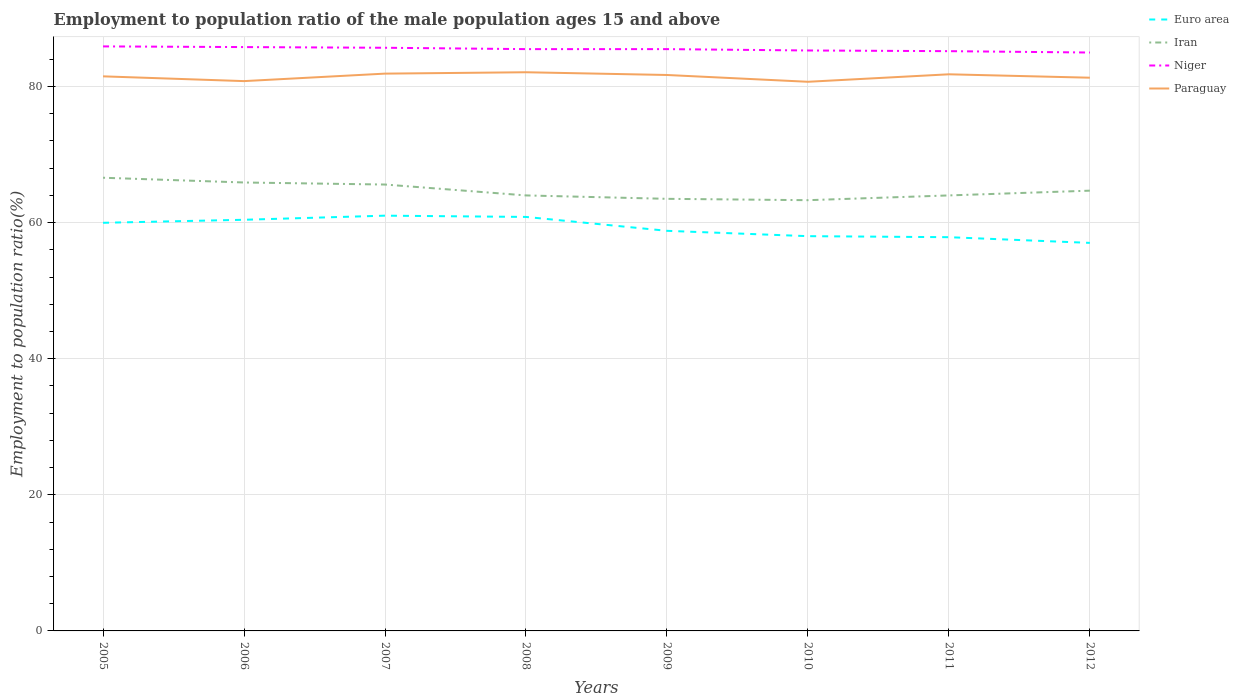How many different coloured lines are there?
Ensure brevity in your answer.  4. Does the line corresponding to Niger intersect with the line corresponding to Paraguay?
Offer a terse response. No. Is the number of lines equal to the number of legend labels?
Offer a very short reply. Yes. In which year was the employment to population ratio in Niger maximum?
Ensure brevity in your answer.  2012. What is the total employment to population ratio in Euro area in the graph?
Make the answer very short. 2.83. What is the difference between the highest and the second highest employment to population ratio in Iran?
Your answer should be compact. 3.3. What is the difference between the highest and the lowest employment to population ratio in Niger?
Your answer should be compact. 5. How many lines are there?
Make the answer very short. 4. How many years are there in the graph?
Your response must be concise. 8. What is the difference between two consecutive major ticks on the Y-axis?
Give a very brief answer. 20. Are the values on the major ticks of Y-axis written in scientific E-notation?
Give a very brief answer. No. Does the graph contain grids?
Provide a succinct answer. Yes. Where does the legend appear in the graph?
Your answer should be compact. Top right. How many legend labels are there?
Make the answer very short. 4. How are the legend labels stacked?
Provide a short and direct response. Vertical. What is the title of the graph?
Ensure brevity in your answer.  Employment to population ratio of the male population ages 15 and above. Does "Seychelles" appear as one of the legend labels in the graph?
Provide a succinct answer. No. What is the Employment to population ratio(%) of Euro area in 2005?
Your response must be concise. 59.98. What is the Employment to population ratio(%) in Iran in 2005?
Provide a short and direct response. 66.6. What is the Employment to population ratio(%) in Niger in 2005?
Ensure brevity in your answer.  85.9. What is the Employment to population ratio(%) in Paraguay in 2005?
Keep it short and to the point. 81.5. What is the Employment to population ratio(%) of Euro area in 2006?
Ensure brevity in your answer.  60.42. What is the Employment to population ratio(%) of Iran in 2006?
Give a very brief answer. 65.9. What is the Employment to population ratio(%) of Niger in 2006?
Make the answer very short. 85.8. What is the Employment to population ratio(%) in Paraguay in 2006?
Offer a terse response. 80.8. What is the Employment to population ratio(%) of Euro area in 2007?
Keep it short and to the point. 61.03. What is the Employment to population ratio(%) of Iran in 2007?
Offer a terse response. 65.6. What is the Employment to population ratio(%) of Niger in 2007?
Provide a succinct answer. 85.7. What is the Employment to population ratio(%) in Paraguay in 2007?
Keep it short and to the point. 81.9. What is the Employment to population ratio(%) in Euro area in 2008?
Give a very brief answer. 60.84. What is the Employment to population ratio(%) in Iran in 2008?
Your response must be concise. 64. What is the Employment to population ratio(%) in Niger in 2008?
Your response must be concise. 85.5. What is the Employment to population ratio(%) in Paraguay in 2008?
Give a very brief answer. 82.1. What is the Employment to population ratio(%) of Euro area in 2009?
Your answer should be compact. 58.8. What is the Employment to population ratio(%) in Iran in 2009?
Your answer should be compact. 63.5. What is the Employment to population ratio(%) of Niger in 2009?
Give a very brief answer. 85.5. What is the Employment to population ratio(%) in Paraguay in 2009?
Your answer should be compact. 81.7. What is the Employment to population ratio(%) in Euro area in 2010?
Provide a short and direct response. 58.01. What is the Employment to population ratio(%) of Iran in 2010?
Make the answer very short. 63.3. What is the Employment to population ratio(%) in Niger in 2010?
Provide a short and direct response. 85.3. What is the Employment to population ratio(%) in Paraguay in 2010?
Your answer should be compact. 80.7. What is the Employment to population ratio(%) in Euro area in 2011?
Offer a terse response. 57.86. What is the Employment to population ratio(%) of Iran in 2011?
Your answer should be very brief. 64. What is the Employment to population ratio(%) in Niger in 2011?
Ensure brevity in your answer.  85.2. What is the Employment to population ratio(%) of Paraguay in 2011?
Make the answer very short. 81.8. What is the Employment to population ratio(%) of Euro area in 2012?
Make the answer very short. 57.02. What is the Employment to population ratio(%) of Iran in 2012?
Your answer should be compact. 64.7. What is the Employment to population ratio(%) in Paraguay in 2012?
Give a very brief answer. 81.3. Across all years, what is the maximum Employment to population ratio(%) of Euro area?
Give a very brief answer. 61.03. Across all years, what is the maximum Employment to population ratio(%) of Iran?
Provide a short and direct response. 66.6. Across all years, what is the maximum Employment to population ratio(%) in Niger?
Ensure brevity in your answer.  85.9. Across all years, what is the maximum Employment to population ratio(%) of Paraguay?
Your answer should be compact. 82.1. Across all years, what is the minimum Employment to population ratio(%) in Euro area?
Provide a short and direct response. 57.02. Across all years, what is the minimum Employment to population ratio(%) of Iran?
Offer a terse response. 63.3. Across all years, what is the minimum Employment to population ratio(%) in Niger?
Offer a very short reply. 85. Across all years, what is the minimum Employment to population ratio(%) of Paraguay?
Provide a succinct answer. 80.7. What is the total Employment to population ratio(%) in Euro area in the graph?
Offer a very short reply. 473.96. What is the total Employment to population ratio(%) of Iran in the graph?
Give a very brief answer. 517.6. What is the total Employment to population ratio(%) in Niger in the graph?
Make the answer very short. 683.9. What is the total Employment to population ratio(%) in Paraguay in the graph?
Your answer should be compact. 651.8. What is the difference between the Employment to population ratio(%) of Euro area in 2005 and that in 2006?
Keep it short and to the point. -0.44. What is the difference between the Employment to population ratio(%) in Niger in 2005 and that in 2006?
Ensure brevity in your answer.  0.1. What is the difference between the Employment to population ratio(%) in Euro area in 2005 and that in 2007?
Offer a terse response. -1.05. What is the difference between the Employment to population ratio(%) in Niger in 2005 and that in 2007?
Offer a terse response. 0.2. What is the difference between the Employment to population ratio(%) of Euro area in 2005 and that in 2008?
Ensure brevity in your answer.  -0.86. What is the difference between the Employment to population ratio(%) in Iran in 2005 and that in 2008?
Ensure brevity in your answer.  2.6. What is the difference between the Employment to population ratio(%) of Euro area in 2005 and that in 2009?
Ensure brevity in your answer.  1.18. What is the difference between the Employment to population ratio(%) of Paraguay in 2005 and that in 2009?
Your answer should be compact. -0.2. What is the difference between the Employment to population ratio(%) in Euro area in 2005 and that in 2010?
Keep it short and to the point. 1.96. What is the difference between the Employment to population ratio(%) of Paraguay in 2005 and that in 2010?
Provide a succinct answer. 0.8. What is the difference between the Employment to population ratio(%) of Euro area in 2005 and that in 2011?
Give a very brief answer. 2.12. What is the difference between the Employment to population ratio(%) of Paraguay in 2005 and that in 2011?
Provide a short and direct response. -0.3. What is the difference between the Employment to population ratio(%) in Euro area in 2005 and that in 2012?
Provide a short and direct response. 2.95. What is the difference between the Employment to population ratio(%) in Niger in 2005 and that in 2012?
Keep it short and to the point. 0.9. What is the difference between the Employment to population ratio(%) in Euro area in 2006 and that in 2007?
Your response must be concise. -0.6. What is the difference between the Employment to population ratio(%) of Iran in 2006 and that in 2007?
Keep it short and to the point. 0.3. What is the difference between the Employment to population ratio(%) of Euro area in 2006 and that in 2008?
Your response must be concise. -0.42. What is the difference between the Employment to population ratio(%) in Paraguay in 2006 and that in 2008?
Offer a terse response. -1.3. What is the difference between the Employment to population ratio(%) in Euro area in 2006 and that in 2009?
Ensure brevity in your answer.  1.62. What is the difference between the Employment to population ratio(%) in Niger in 2006 and that in 2009?
Provide a succinct answer. 0.3. What is the difference between the Employment to population ratio(%) in Paraguay in 2006 and that in 2009?
Your response must be concise. -0.9. What is the difference between the Employment to population ratio(%) in Euro area in 2006 and that in 2010?
Offer a terse response. 2.41. What is the difference between the Employment to population ratio(%) in Iran in 2006 and that in 2010?
Your response must be concise. 2.6. What is the difference between the Employment to population ratio(%) of Paraguay in 2006 and that in 2010?
Offer a very short reply. 0.1. What is the difference between the Employment to population ratio(%) of Euro area in 2006 and that in 2011?
Your answer should be compact. 2.56. What is the difference between the Employment to population ratio(%) in Niger in 2006 and that in 2011?
Your answer should be very brief. 0.6. What is the difference between the Employment to population ratio(%) of Paraguay in 2006 and that in 2011?
Offer a very short reply. -1. What is the difference between the Employment to population ratio(%) in Euro area in 2006 and that in 2012?
Your answer should be compact. 3.4. What is the difference between the Employment to population ratio(%) of Iran in 2006 and that in 2012?
Your answer should be very brief. 1.2. What is the difference between the Employment to population ratio(%) in Niger in 2006 and that in 2012?
Offer a terse response. 0.8. What is the difference between the Employment to population ratio(%) in Paraguay in 2006 and that in 2012?
Give a very brief answer. -0.5. What is the difference between the Employment to population ratio(%) of Euro area in 2007 and that in 2008?
Your response must be concise. 0.19. What is the difference between the Employment to population ratio(%) of Niger in 2007 and that in 2008?
Offer a very short reply. 0.2. What is the difference between the Employment to population ratio(%) in Paraguay in 2007 and that in 2008?
Your answer should be compact. -0.2. What is the difference between the Employment to population ratio(%) of Euro area in 2007 and that in 2009?
Your response must be concise. 2.23. What is the difference between the Employment to population ratio(%) of Niger in 2007 and that in 2009?
Your answer should be compact. 0.2. What is the difference between the Employment to population ratio(%) of Paraguay in 2007 and that in 2009?
Your answer should be very brief. 0.2. What is the difference between the Employment to population ratio(%) in Euro area in 2007 and that in 2010?
Your answer should be compact. 3.01. What is the difference between the Employment to population ratio(%) of Niger in 2007 and that in 2010?
Make the answer very short. 0.4. What is the difference between the Employment to population ratio(%) in Paraguay in 2007 and that in 2010?
Your response must be concise. 1.2. What is the difference between the Employment to population ratio(%) in Euro area in 2007 and that in 2011?
Your answer should be very brief. 3.16. What is the difference between the Employment to population ratio(%) of Iran in 2007 and that in 2011?
Your answer should be compact. 1.6. What is the difference between the Employment to population ratio(%) in Niger in 2007 and that in 2011?
Keep it short and to the point. 0.5. What is the difference between the Employment to population ratio(%) of Paraguay in 2007 and that in 2011?
Provide a short and direct response. 0.1. What is the difference between the Employment to population ratio(%) of Euro area in 2007 and that in 2012?
Your answer should be compact. 4. What is the difference between the Employment to population ratio(%) in Paraguay in 2007 and that in 2012?
Provide a short and direct response. 0.6. What is the difference between the Employment to population ratio(%) of Euro area in 2008 and that in 2009?
Offer a terse response. 2.04. What is the difference between the Employment to population ratio(%) of Euro area in 2008 and that in 2010?
Ensure brevity in your answer.  2.83. What is the difference between the Employment to population ratio(%) in Paraguay in 2008 and that in 2010?
Provide a succinct answer. 1.4. What is the difference between the Employment to population ratio(%) in Euro area in 2008 and that in 2011?
Offer a very short reply. 2.98. What is the difference between the Employment to population ratio(%) in Iran in 2008 and that in 2011?
Give a very brief answer. 0. What is the difference between the Employment to population ratio(%) of Niger in 2008 and that in 2011?
Provide a succinct answer. 0.3. What is the difference between the Employment to population ratio(%) of Paraguay in 2008 and that in 2011?
Provide a short and direct response. 0.3. What is the difference between the Employment to population ratio(%) of Euro area in 2008 and that in 2012?
Offer a very short reply. 3.82. What is the difference between the Employment to population ratio(%) of Niger in 2008 and that in 2012?
Offer a terse response. 0.5. What is the difference between the Employment to population ratio(%) in Paraguay in 2008 and that in 2012?
Offer a very short reply. 0.8. What is the difference between the Employment to population ratio(%) of Euro area in 2009 and that in 2010?
Your response must be concise. 0.78. What is the difference between the Employment to population ratio(%) in Iran in 2009 and that in 2010?
Your answer should be compact. 0.2. What is the difference between the Employment to population ratio(%) of Niger in 2009 and that in 2010?
Your answer should be compact. 0.2. What is the difference between the Employment to population ratio(%) in Euro area in 2009 and that in 2011?
Your response must be concise. 0.94. What is the difference between the Employment to population ratio(%) of Iran in 2009 and that in 2011?
Ensure brevity in your answer.  -0.5. What is the difference between the Employment to population ratio(%) in Niger in 2009 and that in 2011?
Your answer should be very brief. 0.3. What is the difference between the Employment to population ratio(%) in Paraguay in 2009 and that in 2011?
Your answer should be very brief. -0.1. What is the difference between the Employment to population ratio(%) in Euro area in 2009 and that in 2012?
Your response must be concise. 1.77. What is the difference between the Employment to population ratio(%) of Iran in 2009 and that in 2012?
Your answer should be very brief. -1.2. What is the difference between the Employment to population ratio(%) in Niger in 2009 and that in 2012?
Offer a terse response. 0.5. What is the difference between the Employment to population ratio(%) of Euro area in 2010 and that in 2011?
Provide a short and direct response. 0.15. What is the difference between the Employment to population ratio(%) in Euro area in 2010 and that in 2012?
Your answer should be compact. 0.99. What is the difference between the Employment to population ratio(%) of Iran in 2010 and that in 2012?
Make the answer very short. -1.4. What is the difference between the Employment to population ratio(%) of Niger in 2010 and that in 2012?
Provide a short and direct response. 0.3. What is the difference between the Employment to population ratio(%) in Paraguay in 2010 and that in 2012?
Give a very brief answer. -0.6. What is the difference between the Employment to population ratio(%) in Euro area in 2011 and that in 2012?
Offer a very short reply. 0.84. What is the difference between the Employment to population ratio(%) of Iran in 2011 and that in 2012?
Ensure brevity in your answer.  -0.7. What is the difference between the Employment to population ratio(%) in Niger in 2011 and that in 2012?
Keep it short and to the point. 0.2. What is the difference between the Employment to population ratio(%) of Paraguay in 2011 and that in 2012?
Make the answer very short. 0.5. What is the difference between the Employment to population ratio(%) of Euro area in 2005 and the Employment to population ratio(%) of Iran in 2006?
Keep it short and to the point. -5.92. What is the difference between the Employment to population ratio(%) of Euro area in 2005 and the Employment to population ratio(%) of Niger in 2006?
Provide a short and direct response. -25.82. What is the difference between the Employment to population ratio(%) of Euro area in 2005 and the Employment to population ratio(%) of Paraguay in 2006?
Give a very brief answer. -20.82. What is the difference between the Employment to population ratio(%) of Iran in 2005 and the Employment to population ratio(%) of Niger in 2006?
Keep it short and to the point. -19.2. What is the difference between the Employment to population ratio(%) in Iran in 2005 and the Employment to population ratio(%) in Paraguay in 2006?
Offer a very short reply. -14.2. What is the difference between the Employment to population ratio(%) of Euro area in 2005 and the Employment to population ratio(%) of Iran in 2007?
Offer a terse response. -5.62. What is the difference between the Employment to population ratio(%) of Euro area in 2005 and the Employment to population ratio(%) of Niger in 2007?
Offer a very short reply. -25.72. What is the difference between the Employment to population ratio(%) in Euro area in 2005 and the Employment to population ratio(%) in Paraguay in 2007?
Offer a very short reply. -21.92. What is the difference between the Employment to population ratio(%) in Iran in 2005 and the Employment to population ratio(%) in Niger in 2007?
Keep it short and to the point. -19.1. What is the difference between the Employment to population ratio(%) in Iran in 2005 and the Employment to population ratio(%) in Paraguay in 2007?
Your answer should be compact. -15.3. What is the difference between the Employment to population ratio(%) of Euro area in 2005 and the Employment to population ratio(%) of Iran in 2008?
Your answer should be very brief. -4.02. What is the difference between the Employment to population ratio(%) in Euro area in 2005 and the Employment to population ratio(%) in Niger in 2008?
Your response must be concise. -25.52. What is the difference between the Employment to population ratio(%) of Euro area in 2005 and the Employment to population ratio(%) of Paraguay in 2008?
Provide a succinct answer. -22.12. What is the difference between the Employment to population ratio(%) of Iran in 2005 and the Employment to population ratio(%) of Niger in 2008?
Provide a succinct answer. -18.9. What is the difference between the Employment to population ratio(%) in Iran in 2005 and the Employment to population ratio(%) in Paraguay in 2008?
Your response must be concise. -15.5. What is the difference between the Employment to population ratio(%) of Euro area in 2005 and the Employment to population ratio(%) of Iran in 2009?
Your response must be concise. -3.52. What is the difference between the Employment to population ratio(%) in Euro area in 2005 and the Employment to population ratio(%) in Niger in 2009?
Ensure brevity in your answer.  -25.52. What is the difference between the Employment to population ratio(%) of Euro area in 2005 and the Employment to population ratio(%) of Paraguay in 2009?
Your answer should be compact. -21.72. What is the difference between the Employment to population ratio(%) of Iran in 2005 and the Employment to population ratio(%) of Niger in 2009?
Give a very brief answer. -18.9. What is the difference between the Employment to population ratio(%) of Iran in 2005 and the Employment to population ratio(%) of Paraguay in 2009?
Your response must be concise. -15.1. What is the difference between the Employment to population ratio(%) in Euro area in 2005 and the Employment to population ratio(%) in Iran in 2010?
Offer a terse response. -3.32. What is the difference between the Employment to population ratio(%) of Euro area in 2005 and the Employment to population ratio(%) of Niger in 2010?
Keep it short and to the point. -25.32. What is the difference between the Employment to population ratio(%) of Euro area in 2005 and the Employment to population ratio(%) of Paraguay in 2010?
Keep it short and to the point. -20.72. What is the difference between the Employment to population ratio(%) of Iran in 2005 and the Employment to population ratio(%) of Niger in 2010?
Your response must be concise. -18.7. What is the difference between the Employment to population ratio(%) in Iran in 2005 and the Employment to population ratio(%) in Paraguay in 2010?
Offer a terse response. -14.1. What is the difference between the Employment to population ratio(%) in Euro area in 2005 and the Employment to population ratio(%) in Iran in 2011?
Offer a very short reply. -4.02. What is the difference between the Employment to population ratio(%) in Euro area in 2005 and the Employment to population ratio(%) in Niger in 2011?
Offer a very short reply. -25.22. What is the difference between the Employment to population ratio(%) in Euro area in 2005 and the Employment to population ratio(%) in Paraguay in 2011?
Make the answer very short. -21.82. What is the difference between the Employment to population ratio(%) in Iran in 2005 and the Employment to population ratio(%) in Niger in 2011?
Your response must be concise. -18.6. What is the difference between the Employment to population ratio(%) in Iran in 2005 and the Employment to population ratio(%) in Paraguay in 2011?
Keep it short and to the point. -15.2. What is the difference between the Employment to population ratio(%) in Niger in 2005 and the Employment to population ratio(%) in Paraguay in 2011?
Offer a terse response. 4.1. What is the difference between the Employment to population ratio(%) of Euro area in 2005 and the Employment to population ratio(%) of Iran in 2012?
Your response must be concise. -4.72. What is the difference between the Employment to population ratio(%) of Euro area in 2005 and the Employment to population ratio(%) of Niger in 2012?
Offer a very short reply. -25.02. What is the difference between the Employment to population ratio(%) in Euro area in 2005 and the Employment to population ratio(%) in Paraguay in 2012?
Offer a terse response. -21.32. What is the difference between the Employment to population ratio(%) in Iran in 2005 and the Employment to population ratio(%) in Niger in 2012?
Offer a very short reply. -18.4. What is the difference between the Employment to population ratio(%) in Iran in 2005 and the Employment to population ratio(%) in Paraguay in 2012?
Provide a short and direct response. -14.7. What is the difference between the Employment to population ratio(%) of Euro area in 2006 and the Employment to population ratio(%) of Iran in 2007?
Provide a short and direct response. -5.18. What is the difference between the Employment to population ratio(%) of Euro area in 2006 and the Employment to population ratio(%) of Niger in 2007?
Provide a short and direct response. -25.28. What is the difference between the Employment to population ratio(%) in Euro area in 2006 and the Employment to population ratio(%) in Paraguay in 2007?
Keep it short and to the point. -21.48. What is the difference between the Employment to population ratio(%) in Iran in 2006 and the Employment to population ratio(%) in Niger in 2007?
Give a very brief answer. -19.8. What is the difference between the Employment to population ratio(%) in Iran in 2006 and the Employment to population ratio(%) in Paraguay in 2007?
Provide a short and direct response. -16. What is the difference between the Employment to population ratio(%) of Euro area in 2006 and the Employment to population ratio(%) of Iran in 2008?
Provide a short and direct response. -3.58. What is the difference between the Employment to population ratio(%) in Euro area in 2006 and the Employment to population ratio(%) in Niger in 2008?
Offer a very short reply. -25.08. What is the difference between the Employment to population ratio(%) of Euro area in 2006 and the Employment to population ratio(%) of Paraguay in 2008?
Give a very brief answer. -21.68. What is the difference between the Employment to population ratio(%) in Iran in 2006 and the Employment to population ratio(%) in Niger in 2008?
Offer a terse response. -19.6. What is the difference between the Employment to population ratio(%) of Iran in 2006 and the Employment to population ratio(%) of Paraguay in 2008?
Offer a very short reply. -16.2. What is the difference between the Employment to population ratio(%) of Niger in 2006 and the Employment to population ratio(%) of Paraguay in 2008?
Your answer should be compact. 3.7. What is the difference between the Employment to population ratio(%) in Euro area in 2006 and the Employment to population ratio(%) in Iran in 2009?
Ensure brevity in your answer.  -3.08. What is the difference between the Employment to population ratio(%) of Euro area in 2006 and the Employment to population ratio(%) of Niger in 2009?
Keep it short and to the point. -25.08. What is the difference between the Employment to population ratio(%) of Euro area in 2006 and the Employment to population ratio(%) of Paraguay in 2009?
Offer a very short reply. -21.28. What is the difference between the Employment to population ratio(%) of Iran in 2006 and the Employment to population ratio(%) of Niger in 2009?
Ensure brevity in your answer.  -19.6. What is the difference between the Employment to population ratio(%) of Iran in 2006 and the Employment to population ratio(%) of Paraguay in 2009?
Offer a terse response. -15.8. What is the difference between the Employment to population ratio(%) in Euro area in 2006 and the Employment to population ratio(%) in Iran in 2010?
Your response must be concise. -2.88. What is the difference between the Employment to population ratio(%) of Euro area in 2006 and the Employment to population ratio(%) of Niger in 2010?
Your response must be concise. -24.88. What is the difference between the Employment to population ratio(%) in Euro area in 2006 and the Employment to population ratio(%) in Paraguay in 2010?
Your response must be concise. -20.28. What is the difference between the Employment to population ratio(%) of Iran in 2006 and the Employment to population ratio(%) of Niger in 2010?
Keep it short and to the point. -19.4. What is the difference between the Employment to population ratio(%) of Iran in 2006 and the Employment to population ratio(%) of Paraguay in 2010?
Offer a terse response. -14.8. What is the difference between the Employment to population ratio(%) of Euro area in 2006 and the Employment to population ratio(%) of Iran in 2011?
Give a very brief answer. -3.58. What is the difference between the Employment to population ratio(%) of Euro area in 2006 and the Employment to population ratio(%) of Niger in 2011?
Offer a terse response. -24.78. What is the difference between the Employment to population ratio(%) of Euro area in 2006 and the Employment to population ratio(%) of Paraguay in 2011?
Offer a very short reply. -21.38. What is the difference between the Employment to population ratio(%) in Iran in 2006 and the Employment to population ratio(%) in Niger in 2011?
Provide a short and direct response. -19.3. What is the difference between the Employment to population ratio(%) in Iran in 2006 and the Employment to population ratio(%) in Paraguay in 2011?
Make the answer very short. -15.9. What is the difference between the Employment to population ratio(%) in Niger in 2006 and the Employment to population ratio(%) in Paraguay in 2011?
Give a very brief answer. 4. What is the difference between the Employment to population ratio(%) of Euro area in 2006 and the Employment to population ratio(%) of Iran in 2012?
Provide a succinct answer. -4.28. What is the difference between the Employment to population ratio(%) of Euro area in 2006 and the Employment to population ratio(%) of Niger in 2012?
Give a very brief answer. -24.58. What is the difference between the Employment to population ratio(%) in Euro area in 2006 and the Employment to population ratio(%) in Paraguay in 2012?
Offer a terse response. -20.88. What is the difference between the Employment to population ratio(%) of Iran in 2006 and the Employment to population ratio(%) of Niger in 2012?
Your answer should be very brief. -19.1. What is the difference between the Employment to population ratio(%) of Iran in 2006 and the Employment to population ratio(%) of Paraguay in 2012?
Make the answer very short. -15.4. What is the difference between the Employment to population ratio(%) of Euro area in 2007 and the Employment to population ratio(%) of Iran in 2008?
Ensure brevity in your answer.  -2.97. What is the difference between the Employment to population ratio(%) in Euro area in 2007 and the Employment to population ratio(%) in Niger in 2008?
Make the answer very short. -24.47. What is the difference between the Employment to population ratio(%) in Euro area in 2007 and the Employment to population ratio(%) in Paraguay in 2008?
Give a very brief answer. -21.07. What is the difference between the Employment to population ratio(%) in Iran in 2007 and the Employment to population ratio(%) in Niger in 2008?
Ensure brevity in your answer.  -19.9. What is the difference between the Employment to population ratio(%) in Iran in 2007 and the Employment to population ratio(%) in Paraguay in 2008?
Give a very brief answer. -16.5. What is the difference between the Employment to population ratio(%) in Euro area in 2007 and the Employment to population ratio(%) in Iran in 2009?
Give a very brief answer. -2.47. What is the difference between the Employment to population ratio(%) of Euro area in 2007 and the Employment to population ratio(%) of Niger in 2009?
Offer a terse response. -24.47. What is the difference between the Employment to population ratio(%) of Euro area in 2007 and the Employment to population ratio(%) of Paraguay in 2009?
Offer a very short reply. -20.67. What is the difference between the Employment to population ratio(%) of Iran in 2007 and the Employment to population ratio(%) of Niger in 2009?
Your answer should be compact. -19.9. What is the difference between the Employment to population ratio(%) in Iran in 2007 and the Employment to population ratio(%) in Paraguay in 2009?
Keep it short and to the point. -16.1. What is the difference between the Employment to population ratio(%) in Niger in 2007 and the Employment to population ratio(%) in Paraguay in 2009?
Keep it short and to the point. 4. What is the difference between the Employment to population ratio(%) in Euro area in 2007 and the Employment to population ratio(%) in Iran in 2010?
Your answer should be very brief. -2.27. What is the difference between the Employment to population ratio(%) of Euro area in 2007 and the Employment to population ratio(%) of Niger in 2010?
Offer a very short reply. -24.27. What is the difference between the Employment to population ratio(%) in Euro area in 2007 and the Employment to population ratio(%) in Paraguay in 2010?
Offer a terse response. -19.67. What is the difference between the Employment to population ratio(%) in Iran in 2007 and the Employment to population ratio(%) in Niger in 2010?
Your answer should be very brief. -19.7. What is the difference between the Employment to population ratio(%) in Iran in 2007 and the Employment to population ratio(%) in Paraguay in 2010?
Provide a short and direct response. -15.1. What is the difference between the Employment to population ratio(%) in Euro area in 2007 and the Employment to population ratio(%) in Iran in 2011?
Provide a short and direct response. -2.97. What is the difference between the Employment to population ratio(%) in Euro area in 2007 and the Employment to population ratio(%) in Niger in 2011?
Offer a terse response. -24.17. What is the difference between the Employment to population ratio(%) of Euro area in 2007 and the Employment to population ratio(%) of Paraguay in 2011?
Provide a short and direct response. -20.77. What is the difference between the Employment to population ratio(%) of Iran in 2007 and the Employment to population ratio(%) of Niger in 2011?
Your answer should be compact. -19.6. What is the difference between the Employment to population ratio(%) of Iran in 2007 and the Employment to population ratio(%) of Paraguay in 2011?
Give a very brief answer. -16.2. What is the difference between the Employment to population ratio(%) in Niger in 2007 and the Employment to population ratio(%) in Paraguay in 2011?
Keep it short and to the point. 3.9. What is the difference between the Employment to population ratio(%) of Euro area in 2007 and the Employment to population ratio(%) of Iran in 2012?
Make the answer very short. -3.67. What is the difference between the Employment to population ratio(%) of Euro area in 2007 and the Employment to population ratio(%) of Niger in 2012?
Provide a short and direct response. -23.97. What is the difference between the Employment to population ratio(%) in Euro area in 2007 and the Employment to population ratio(%) in Paraguay in 2012?
Provide a short and direct response. -20.27. What is the difference between the Employment to population ratio(%) in Iran in 2007 and the Employment to population ratio(%) in Niger in 2012?
Offer a very short reply. -19.4. What is the difference between the Employment to population ratio(%) in Iran in 2007 and the Employment to population ratio(%) in Paraguay in 2012?
Keep it short and to the point. -15.7. What is the difference between the Employment to population ratio(%) in Euro area in 2008 and the Employment to population ratio(%) in Iran in 2009?
Your response must be concise. -2.66. What is the difference between the Employment to population ratio(%) in Euro area in 2008 and the Employment to population ratio(%) in Niger in 2009?
Your answer should be very brief. -24.66. What is the difference between the Employment to population ratio(%) of Euro area in 2008 and the Employment to population ratio(%) of Paraguay in 2009?
Make the answer very short. -20.86. What is the difference between the Employment to population ratio(%) in Iran in 2008 and the Employment to population ratio(%) in Niger in 2009?
Your answer should be compact. -21.5. What is the difference between the Employment to population ratio(%) in Iran in 2008 and the Employment to population ratio(%) in Paraguay in 2009?
Give a very brief answer. -17.7. What is the difference between the Employment to population ratio(%) in Niger in 2008 and the Employment to population ratio(%) in Paraguay in 2009?
Provide a short and direct response. 3.8. What is the difference between the Employment to population ratio(%) of Euro area in 2008 and the Employment to population ratio(%) of Iran in 2010?
Give a very brief answer. -2.46. What is the difference between the Employment to population ratio(%) of Euro area in 2008 and the Employment to population ratio(%) of Niger in 2010?
Provide a short and direct response. -24.46. What is the difference between the Employment to population ratio(%) of Euro area in 2008 and the Employment to population ratio(%) of Paraguay in 2010?
Make the answer very short. -19.86. What is the difference between the Employment to population ratio(%) of Iran in 2008 and the Employment to population ratio(%) of Niger in 2010?
Offer a very short reply. -21.3. What is the difference between the Employment to population ratio(%) of Iran in 2008 and the Employment to population ratio(%) of Paraguay in 2010?
Offer a terse response. -16.7. What is the difference between the Employment to population ratio(%) of Niger in 2008 and the Employment to population ratio(%) of Paraguay in 2010?
Offer a very short reply. 4.8. What is the difference between the Employment to population ratio(%) in Euro area in 2008 and the Employment to population ratio(%) in Iran in 2011?
Provide a short and direct response. -3.16. What is the difference between the Employment to population ratio(%) in Euro area in 2008 and the Employment to population ratio(%) in Niger in 2011?
Provide a short and direct response. -24.36. What is the difference between the Employment to population ratio(%) of Euro area in 2008 and the Employment to population ratio(%) of Paraguay in 2011?
Offer a terse response. -20.96. What is the difference between the Employment to population ratio(%) of Iran in 2008 and the Employment to population ratio(%) of Niger in 2011?
Keep it short and to the point. -21.2. What is the difference between the Employment to population ratio(%) of Iran in 2008 and the Employment to population ratio(%) of Paraguay in 2011?
Make the answer very short. -17.8. What is the difference between the Employment to population ratio(%) in Niger in 2008 and the Employment to population ratio(%) in Paraguay in 2011?
Provide a short and direct response. 3.7. What is the difference between the Employment to population ratio(%) in Euro area in 2008 and the Employment to population ratio(%) in Iran in 2012?
Ensure brevity in your answer.  -3.86. What is the difference between the Employment to population ratio(%) in Euro area in 2008 and the Employment to population ratio(%) in Niger in 2012?
Provide a succinct answer. -24.16. What is the difference between the Employment to population ratio(%) in Euro area in 2008 and the Employment to population ratio(%) in Paraguay in 2012?
Offer a terse response. -20.46. What is the difference between the Employment to population ratio(%) in Iran in 2008 and the Employment to population ratio(%) in Niger in 2012?
Ensure brevity in your answer.  -21. What is the difference between the Employment to population ratio(%) in Iran in 2008 and the Employment to population ratio(%) in Paraguay in 2012?
Make the answer very short. -17.3. What is the difference between the Employment to population ratio(%) in Euro area in 2009 and the Employment to population ratio(%) in Iran in 2010?
Ensure brevity in your answer.  -4.5. What is the difference between the Employment to population ratio(%) of Euro area in 2009 and the Employment to population ratio(%) of Niger in 2010?
Make the answer very short. -26.5. What is the difference between the Employment to population ratio(%) in Euro area in 2009 and the Employment to population ratio(%) in Paraguay in 2010?
Your answer should be compact. -21.9. What is the difference between the Employment to population ratio(%) of Iran in 2009 and the Employment to population ratio(%) of Niger in 2010?
Provide a succinct answer. -21.8. What is the difference between the Employment to population ratio(%) of Iran in 2009 and the Employment to population ratio(%) of Paraguay in 2010?
Offer a terse response. -17.2. What is the difference between the Employment to population ratio(%) in Niger in 2009 and the Employment to population ratio(%) in Paraguay in 2010?
Keep it short and to the point. 4.8. What is the difference between the Employment to population ratio(%) of Euro area in 2009 and the Employment to population ratio(%) of Iran in 2011?
Ensure brevity in your answer.  -5.2. What is the difference between the Employment to population ratio(%) in Euro area in 2009 and the Employment to population ratio(%) in Niger in 2011?
Keep it short and to the point. -26.4. What is the difference between the Employment to population ratio(%) in Euro area in 2009 and the Employment to population ratio(%) in Paraguay in 2011?
Offer a terse response. -23. What is the difference between the Employment to population ratio(%) of Iran in 2009 and the Employment to population ratio(%) of Niger in 2011?
Offer a terse response. -21.7. What is the difference between the Employment to population ratio(%) in Iran in 2009 and the Employment to population ratio(%) in Paraguay in 2011?
Your answer should be very brief. -18.3. What is the difference between the Employment to population ratio(%) in Niger in 2009 and the Employment to population ratio(%) in Paraguay in 2011?
Ensure brevity in your answer.  3.7. What is the difference between the Employment to population ratio(%) in Euro area in 2009 and the Employment to population ratio(%) in Iran in 2012?
Your answer should be compact. -5.9. What is the difference between the Employment to population ratio(%) of Euro area in 2009 and the Employment to population ratio(%) of Niger in 2012?
Offer a very short reply. -26.2. What is the difference between the Employment to population ratio(%) in Euro area in 2009 and the Employment to population ratio(%) in Paraguay in 2012?
Keep it short and to the point. -22.5. What is the difference between the Employment to population ratio(%) of Iran in 2009 and the Employment to population ratio(%) of Niger in 2012?
Offer a terse response. -21.5. What is the difference between the Employment to population ratio(%) in Iran in 2009 and the Employment to population ratio(%) in Paraguay in 2012?
Keep it short and to the point. -17.8. What is the difference between the Employment to population ratio(%) of Niger in 2009 and the Employment to population ratio(%) of Paraguay in 2012?
Offer a very short reply. 4.2. What is the difference between the Employment to population ratio(%) of Euro area in 2010 and the Employment to population ratio(%) of Iran in 2011?
Offer a terse response. -5.99. What is the difference between the Employment to population ratio(%) in Euro area in 2010 and the Employment to population ratio(%) in Niger in 2011?
Your answer should be compact. -27.19. What is the difference between the Employment to population ratio(%) in Euro area in 2010 and the Employment to population ratio(%) in Paraguay in 2011?
Provide a succinct answer. -23.79. What is the difference between the Employment to population ratio(%) of Iran in 2010 and the Employment to population ratio(%) of Niger in 2011?
Ensure brevity in your answer.  -21.9. What is the difference between the Employment to population ratio(%) of Iran in 2010 and the Employment to population ratio(%) of Paraguay in 2011?
Your answer should be very brief. -18.5. What is the difference between the Employment to population ratio(%) in Euro area in 2010 and the Employment to population ratio(%) in Iran in 2012?
Offer a terse response. -6.69. What is the difference between the Employment to population ratio(%) in Euro area in 2010 and the Employment to population ratio(%) in Niger in 2012?
Give a very brief answer. -26.99. What is the difference between the Employment to population ratio(%) in Euro area in 2010 and the Employment to population ratio(%) in Paraguay in 2012?
Provide a short and direct response. -23.29. What is the difference between the Employment to population ratio(%) in Iran in 2010 and the Employment to population ratio(%) in Niger in 2012?
Your answer should be compact. -21.7. What is the difference between the Employment to population ratio(%) in Euro area in 2011 and the Employment to population ratio(%) in Iran in 2012?
Offer a terse response. -6.84. What is the difference between the Employment to population ratio(%) of Euro area in 2011 and the Employment to population ratio(%) of Niger in 2012?
Your answer should be very brief. -27.14. What is the difference between the Employment to population ratio(%) in Euro area in 2011 and the Employment to population ratio(%) in Paraguay in 2012?
Ensure brevity in your answer.  -23.44. What is the difference between the Employment to population ratio(%) of Iran in 2011 and the Employment to population ratio(%) of Niger in 2012?
Make the answer very short. -21. What is the difference between the Employment to population ratio(%) in Iran in 2011 and the Employment to population ratio(%) in Paraguay in 2012?
Your answer should be compact. -17.3. What is the average Employment to population ratio(%) of Euro area per year?
Your response must be concise. 59.25. What is the average Employment to population ratio(%) in Iran per year?
Your answer should be very brief. 64.7. What is the average Employment to population ratio(%) of Niger per year?
Give a very brief answer. 85.49. What is the average Employment to population ratio(%) of Paraguay per year?
Offer a very short reply. 81.47. In the year 2005, what is the difference between the Employment to population ratio(%) of Euro area and Employment to population ratio(%) of Iran?
Make the answer very short. -6.62. In the year 2005, what is the difference between the Employment to population ratio(%) of Euro area and Employment to population ratio(%) of Niger?
Offer a terse response. -25.92. In the year 2005, what is the difference between the Employment to population ratio(%) in Euro area and Employment to population ratio(%) in Paraguay?
Your answer should be very brief. -21.52. In the year 2005, what is the difference between the Employment to population ratio(%) in Iran and Employment to population ratio(%) in Niger?
Your answer should be compact. -19.3. In the year 2005, what is the difference between the Employment to population ratio(%) in Iran and Employment to population ratio(%) in Paraguay?
Make the answer very short. -14.9. In the year 2005, what is the difference between the Employment to population ratio(%) of Niger and Employment to population ratio(%) of Paraguay?
Provide a short and direct response. 4.4. In the year 2006, what is the difference between the Employment to population ratio(%) of Euro area and Employment to population ratio(%) of Iran?
Your answer should be very brief. -5.48. In the year 2006, what is the difference between the Employment to population ratio(%) in Euro area and Employment to population ratio(%) in Niger?
Give a very brief answer. -25.38. In the year 2006, what is the difference between the Employment to population ratio(%) of Euro area and Employment to population ratio(%) of Paraguay?
Your answer should be very brief. -20.38. In the year 2006, what is the difference between the Employment to population ratio(%) of Iran and Employment to population ratio(%) of Niger?
Provide a succinct answer. -19.9. In the year 2006, what is the difference between the Employment to population ratio(%) of Iran and Employment to population ratio(%) of Paraguay?
Ensure brevity in your answer.  -14.9. In the year 2007, what is the difference between the Employment to population ratio(%) in Euro area and Employment to population ratio(%) in Iran?
Your response must be concise. -4.57. In the year 2007, what is the difference between the Employment to population ratio(%) of Euro area and Employment to population ratio(%) of Niger?
Ensure brevity in your answer.  -24.67. In the year 2007, what is the difference between the Employment to population ratio(%) in Euro area and Employment to population ratio(%) in Paraguay?
Provide a succinct answer. -20.87. In the year 2007, what is the difference between the Employment to population ratio(%) in Iran and Employment to population ratio(%) in Niger?
Your response must be concise. -20.1. In the year 2007, what is the difference between the Employment to population ratio(%) in Iran and Employment to population ratio(%) in Paraguay?
Make the answer very short. -16.3. In the year 2008, what is the difference between the Employment to population ratio(%) in Euro area and Employment to population ratio(%) in Iran?
Your response must be concise. -3.16. In the year 2008, what is the difference between the Employment to population ratio(%) of Euro area and Employment to population ratio(%) of Niger?
Your response must be concise. -24.66. In the year 2008, what is the difference between the Employment to population ratio(%) of Euro area and Employment to population ratio(%) of Paraguay?
Your response must be concise. -21.26. In the year 2008, what is the difference between the Employment to population ratio(%) of Iran and Employment to population ratio(%) of Niger?
Offer a terse response. -21.5. In the year 2008, what is the difference between the Employment to population ratio(%) in Iran and Employment to population ratio(%) in Paraguay?
Provide a short and direct response. -18.1. In the year 2009, what is the difference between the Employment to population ratio(%) in Euro area and Employment to population ratio(%) in Iran?
Offer a very short reply. -4.7. In the year 2009, what is the difference between the Employment to population ratio(%) in Euro area and Employment to population ratio(%) in Niger?
Give a very brief answer. -26.7. In the year 2009, what is the difference between the Employment to population ratio(%) of Euro area and Employment to population ratio(%) of Paraguay?
Your response must be concise. -22.9. In the year 2009, what is the difference between the Employment to population ratio(%) in Iran and Employment to population ratio(%) in Niger?
Keep it short and to the point. -22. In the year 2009, what is the difference between the Employment to population ratio(%) in Iran and Employment to population ratio(%) in Paraguay?
Offer a terse response. -18.2. In the year 2010, what is the difference between the Employment to population ratio(%) of Euro area and Employment to population ratio(%) of Iran?
Provide a short and direct response. -5.29. In the year 2010, what is the difference between the Employment to population ratio(%) in Euro area and Employment to population ratio(%) in Niger?
Offer a very short reply. -27.29. In the year 2010, what is the difference between the Employment to population ratio(%) of Euro area and Employment to population ratio(%) of Paraguay?
Offer a terse response. -22.69. In the year 2010, what is the difference between the Employment to population ratio(%) in Iran and Employment to population ratio(%) in Paraguay?
Provide a succinct answer. -17.4. In the year 2011, what is the difference between the Employment to population ratio(%) of Euro area and Employment to population ratio(%) of Iran?
Give a very brief answer. -6.14. In the year 2011, what is the difference between the Employment to population ratio(%) of Euro area and Employment to population ratio(%) of Niger?
Provide a short and direct response. -27.34. In the year 2011, what is the difference between the Employment to population ratio(%) in Euro area and Employment to population ratio(%) in Paraguay?
Your answer should be compact. -23.94. In the year 2011, what is the difference between the Employment to population ratio(%) of Iran and Employment to population ratio(%) of Niger?
Your answer should be very brief. -21.2. In the year 2011, what is the difference between the Employment to population ratio(%) of Iran and Employment to population ratio(%) of Paraguay?
Keep it short and to the point. -17.8. In the year 2011, what is the difference between the Employment to population ratio(%) of Niger and Employment to population ratio(%) of Paraguay?
Offer a very short reply. 3.4. In the year 2012, what is the difference between the Employment to population ratio(%) in Euro area and Employment to population ratio(%) in Iran?
Your answer should be compact. -7.68. In the year 2012, what is the difference between the Employment to population ratio(%) of Euro area and Employment to population ratio(%) of Niger?
Ensure brevity in your answer.  -27.98. In the year 2012, what is the difference between the Employment to population ratio(%) of Euro area and Employment to population ratio(%) of Paraguay?
Give a very brief answer. -24.28. In the year 2012, what is the difference between the Employment to population ratio(%) of Iran and Employment to population ratio(%) of Niger?
Your answer should be compact. -20.3. In the year 2012, what is the difference between the Employment to population ratio(%) of Iran and Employment to population ratio(%) of Paraguay?
Make the answer very short. -16.6. In the year 2012, what is the difference between the Employment to population ratio(%) of Niger and Employment to population ratio(%) of Paraguay?
Your answer should be compact. 3.7. What is the ratio of the Employment to population ratio(%) in Iran in 2005 to that in 2006?
Provide a succinct answer. 1.01. What is the ratio of the Employment to population ratio(%) in Niger in 2005 to that in 2006?
Your response must be concise. 1. What is the ratio of the Employment to population ratio(%) of Paraguay in 2005 to that in 2006?
Provide a short and direct response. 1.01. What is the ratio of the Employment to population ratio(%) in Euro area in 2005 to that in 2007?
Make the answer very short. 0.98. What is the ratio of the Employment to population ratio(%) in Iran in 2005 to that in 2007?
Your answer should be compact. 1.02. What is the ratio of the Employment to population ratio(%) of Euro area in 2005 to that in 2008?
Offer a very short reply. 0.99. What is the ratio of the Employment to population ratio(%) in Iran in 2005 to that in 2008?
Your answer should be very brief. 1.04. What is the ratio of the Employment to population ratio(%) in Niger in 2005 to that in 2008?
Offer a terse response. 1. What is the ratio of the Employment to population ratio(%) of Paraguay in 2005 to that in 2008?
Offer a very short reply. 0.99. What is the ratio of the Employment to population ratio(%) of Euro area in 2005 to that in 2009?
Offer a very short reply. 1.02. What is the ratio of the Employment to population ratio(%) of Iran in 2005 to that in 2009?
Keep it short and to the point. 1.05. What is the ratio of the Employment to population ratio(%) of Euro area in 2005 to that in 2010?
Your answer should be very brief. 1.03. What is the ratio of the Employment to population ratio(%) of Iran in 2005 to that in 2010?
Provide a short and direct response. 1.05. What is the ratio of the Employment to population ratio(%) in Niger in 2005 to that in 2010?
Offer a very short reply. 1.01. What is the ratio of the Employment to population ratio(%) in Paraguay in 2005 to that in 2010?
Offer a very short reply. 1.01. What is the ratio of the Employment to population ratio(%) in Euro area in 2005 to that in 2011?
Give a very brief answer. 1.04. What is the ratio of the Employment to population ratio(%) in Iran in 2005 to that in 2011?
Your answer should be compact. 1.04. What is the ratio of the Employment to population ratio(%) of Niger in 2005 to that in 2011?
Your response must be concise. 1.01. What is the ratio of the Employment to population ratio(%) in Paraguay in 2005 to that in 2011?
Your response must be concise. 1. What is the ratio of the Employment to population ratio(%) of Euro area in 2005 to that in 2012?
Ensure brevity in your answer.  1.05. What is the ratio of the Employment to population ratio(%) in Iran in 2005 to that in 2012?
Make the answer very short. 1.03. What is the ratio of the Employment to population ratio(%) in Niger in 2005 to that in 2012?
Your response must be concise. 1.01. What is the ratio of the Employment to population ratio(%) in Euro area in 2006 to that in 2007?
Your answer should be compact. 0.99. What is the ratio of the Employment to population ratio(%) of Niger in 2006 to that in 2007?
Provide a short and direct response. 1. What is the ratio of the Employment to population ratio(%) in Paraguay in 2006 to that in 2007?
Your answer should be compact. 0.99. What is the ratio of the Employment to population ratio(%) of Iran in 2006 to that in 2008?
Provide a short and direct response. 1.03. What is the ratio of the Employment to population ratio(%) of Paraguay in 2006 to that in 2008?
Your answer should be very brief. 0.98. What is the ratio of the Employment to population ratio(%) of Euro area in 2006 to that in 2009?
Keep it short and to the point. 1.03. What is the ratio of the Employment to population ratio(%) of Iran in 2006 to that in 2009?
Offer a terse response. 1.04. What is the ratio of the Employment to population ratio(%) in Niger in 2006 to that in 2009?
Ensure brevity in your answer.  1. What is the ratio of the Employment to population ratio(%) of Euro area in 2006 to that in 2010?
Keep it short and to the point. 1.04. What is the ratio of the Employment to population ratio(%) of Iran in 2006 to that in 2010?
Keep it short and to the point. 1.04. What is the ratio of the Employment to population ratio(%) in Niger in 2006 to that in 2010?
Ensure brevity in your answer.  1.01. What is the ratio of the Employment to population ratio(%) in Euro area in 2006 to that in 2011?
Provide a succinct answer. 1.04. What is the ratio of the Employment to population ratio(%) of Iran in 2006 to that in 2011?
Your answer should be very brief. 1.03. What is the ratio of the Employment to population ratio(%) of Euro area in 2006 to that in 2012?
Provide a succinct answer. 1.06. What is the ratio of the Employment to population ratio(%) in Iran in 2006 to that in 2012?
Give a very brief answer. 1.02. What is the ratio of the Employment to population ratio(%) of Niger in 2006 to that in 2012?
Offer a very short reply. 1.01. What is the ratio of the Employment to population ratio(%) of Euro area in 2007 to that in 2008?
Provide a short and direct response. 1. What is the ratio of the Employment to population ratio(%) in Iran in 2007 to that in 2008?
Give a very brief answer. 1.02. What is the ratio of the Employment to population ratio(%) in Paraguay in 2007 to that in 2008?
Give a very brief answer. 1. What is the ratio of the Employment to population ratio(%) in Euro area in 2007 to that in 2009?
Make the answer very short. 1.04. What is the ratio of the Employment to population ratio(%) in Iran in 2007 to that in 2009?
Ensure brevity in your answer.  1.03. What is the ratio of the Employment to population ratio(%) of Niger in 2007 to that in 2009?
Your answer should be very brief. 1. What is the ratio of the Employment to population ratio(%) in Paraguay in 2007 to that in 2009?
Ensure brevity in your answer.  1. What is the ratio of the Employment to population ratio(%) of Euro area in 2007 to that in 2010?
Your answer should be compact. 1.05. What is the ratio of the Employment to population ratio(%) in Iran in 2007 to that in 2010?
Offer a very short reply. 1.04. What is the ratio of the Employment to population ratio(%) of Paraguay in 2007 to that in 2010?
Offer a terse response. 1.01. What is the ratio of the Employment to population ratio(%) in Euro area in 2007 to that in 2011?
Provide a short and direct response. 1.05. What is the ratio of the Employment to population ratio(%) of Iran in 2007 to that in 2011?
Provide a succinct answer. 1.02. What is the ratio of the Employment to population ratio(%) in Niger in 2007 to that in 2011?
Make the answer very short. 1.01. What is the ratio of the Employment to population ratio(%) of Euro area in 2007 to that in 2012?
Offer a very short reply. 1.07. What is the ratio of the Employment to population ratio(%) in Iran in 2007 to that in 2012?
Provide a short and direct response. 1.01. What is the ratio of the Employment to population ratio(%) in Niger in 2007 to that in 2012?
Provide a short and direct response. 1.01. What is the ratio of the Employment to population ratio(%) in Paraguay in 2007 to that in 2012?
Offer a very short reply. 1.01. What is the ratio of the Employment to population ratio(%) of Euro area in 2008 to that in 2009?
Offer a terse response. 1.03. What is the ratio of the Employment to population ratio(%) in Iran in 2008 to that in 2009?
Make the answer very short. 1.01. What is the ratio of the Employment to population ratio(%) of Niger in 2008 to that in 2009?
Provide a short and direct response. 1. What is the ratio of the Employment to population ratio(%) in Euro area in 2008 to that in 2010?
Offer a terse response. 1.05. What is the ratio of the Employment to population ratio(%) of Iran in 2008 to that in 2010?
Your answer should be very brief. 1.01. What is the ratio of the Employment to population ratio(%) of Paraguay in 2008 to that in 2010?
Keep it short and to the point. 1.02. What is the ratio of the Employment to population ratio(%) of Euro area in 2008 to that in 2011?
Offer a terse response. 1.05. What is the ratio of the Employment to population ratio(%) of Iran in 2008 to that in 2011?
Provide a short and direct response. 1. What is the ratio of the Employment to population ratio(%) in Euro area in 2008 to that in 2012?
Provide a short and direct response. 1.07. What is the ratio of the Employment to population ratio(%) of Niger in 2008 to that in 2012?
Ensure brevity in your answer.  1.01. What is the ratio of the Employment to population ratio(%) of Paraguay in 2008 to that in 2012?
Your answer should be very brief. 1.01. What is the ratio of the Employment to population ratio(%) in Euro area in 2009 to that in 2010?
Keep it short and to the point. 1.01. What is the ratio of the Employment to population ratio(%) in Niger in 2009 to that in 2010?
Give a very brief answer. 1. What is the ratio of the Employment to population ratio(%) of Paraguay in 2009 to that in 2010?
Your answer should be compact. 1.01. What is the ratio of the Employment to population ratio(%) of Euro area in 2009 to that in 2011?
Make the answer very short. 1.02. What is the ratio of the Employment to population ratio(%) of Iran in 2009 to that in 2011?
Ensure brevity in your answer.  0.99. What is the ratio of the Employment to population ratio(%) in Paraguay in 2009 to that in 2011?
Offer a very short reply. 1. What is the ratio of the Employment to population ratio(%) of Euro area in 2009 to that in 2012?
Your answer should be compact. 1.03. What is the ratio of the Employment to population ratio(%) of Iran in 2009 to that in 2012?
Make the answer very short. 0.98. What is the ratio of the Employment to population ratio(%) in Niger in 2009 to that in 2012?
Give a very brief answer. 1.01. What is the ratio of the Employment to population ratio(%) of Euro area in 2010 to that in 2011?
Make the answer very short. 1. What is the ratio of the Employment to population ratio(%) in Niger in 2010 to that in 2011?
Provide a succinct answer. 1. What is the ratio of the Employment to population ratio(%) of Paraguay in 2010 to that in 2011?
Offer a very short reply. 0.99. What is the ratio of the Employment to population ratio(%) in Euro area in 2010 to that in 2012?
Your answer should be compact. 1.02. What is the ratio of the Employment to population ratio(%) of Iran in 2010 to that in 2012?
Make the answer very short. 0.98. What is the ratio of the Employment to population ratio(%) of Niger in 2010 to that in 2012?
Ensure brevity in your answer.  1. What is the ratio of the Employment to population ratio(%) in Euro area in 2011 to that in 2012?
Offer a terse response. 1.01. What is the ratio of the Employment to population ratio(%) of Niger in 2011 to that in 2012?
Provide a succinct answer. 1. What is the difference between the highest and the second highest Employment to population ratio(%) in Euro area?
Offer a terse response. 0.19. What is the difference between the highest and the second highest Employment to population ratio(%) in Paraguay?
Offer a terse response. 0.2. What is the difference between the highest and the lowest Employment to population ratio(%) in Euro area?
Your answer should be compact. 4. What is the difference between the highest and the lowest Employment to population ratio(%) of Iran?
Your answer should be very brief. 3.3. What is the difference between the highest and the lowest Employment to population ratio(%) of Niger?
Provide a short and direct response. 0.9. 